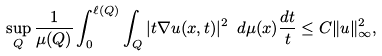<formula> <loc_0><loc_0><loc_500><loc_500>\sup _ { Q } \frac { 1 } { \mu ( Q ) } \int _ { 0 } ^ { \ell ( Q ) } \int _ { Q } | t \nabla u ( x , t ) | ^ { 2 } \ d \mu ( x ) \frac { d t } { t } \leq C \| u \| _ { \infty } ^ { 2 } ,</formula> 